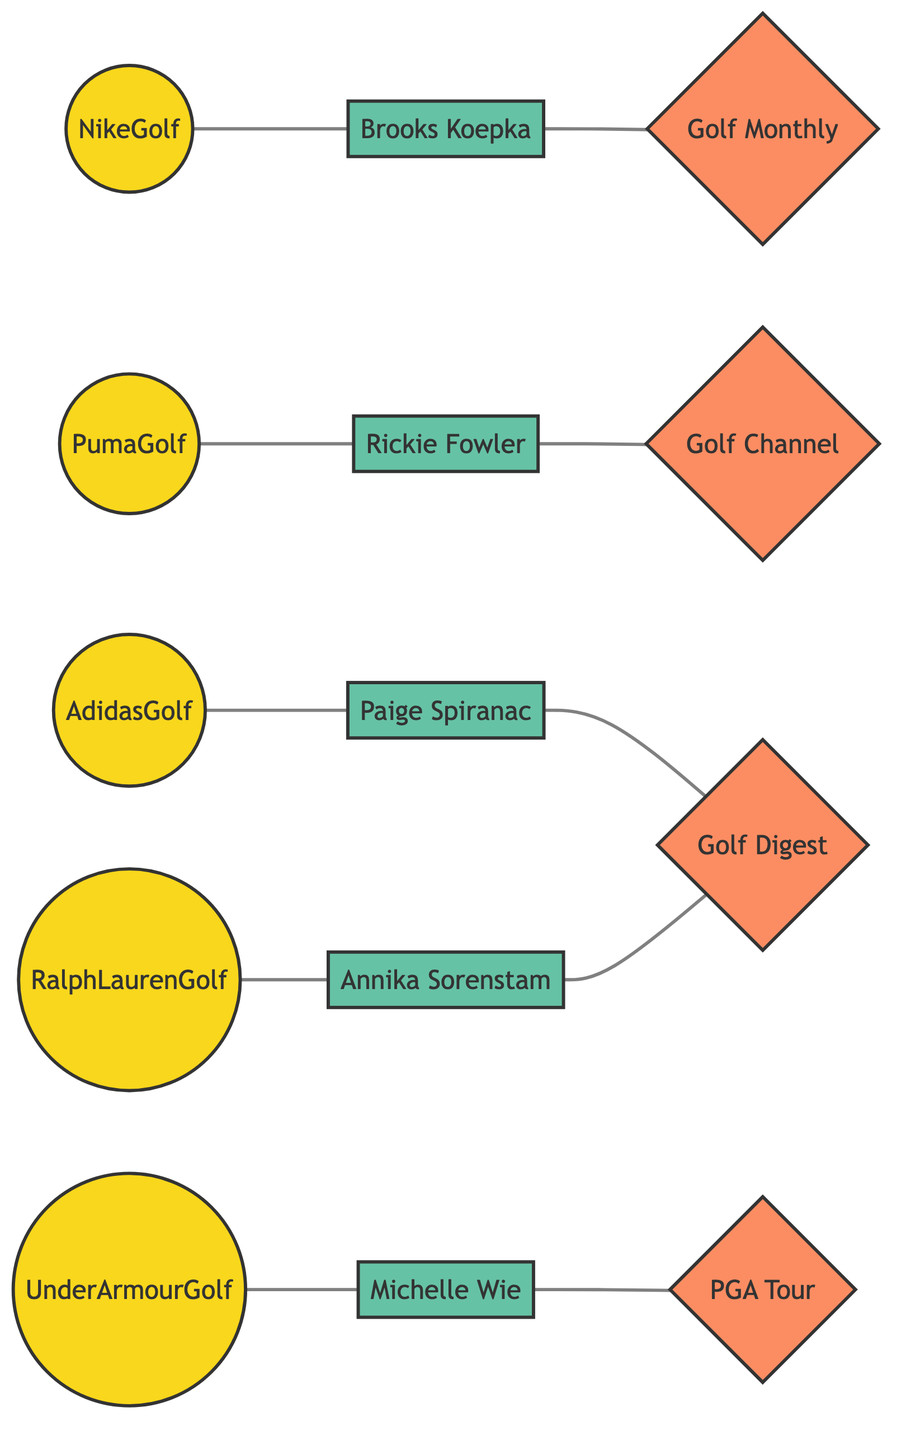What is the total number of nodes in the diagram? The diagram includes both brands and influencers, plus media entities. By counting all unique nodes listed, we find there are 13 nodes in total.
Answer: 13 Which influencer is associated with Nike Golf? The diagram shows a direct edge connecting Nike Golf and Brooks Koepka. This indicates that Brooks Koepka is the influencer associated with Nike Golf.
Answer: Brooks Koepka How many collaborations are featured in the diagram? By examining the edges, we note that there are 5 edges labeled as collaborations connecting different brands to influencers. This gives us a total of 5 collaboration relationships.
Answer: 5 Which brand is connected to GolfDigest? The edges indicate that Paige Spiranac and Annika Sorenstam are both connected to GolfDigest. Therefore, the brands associated with GolfDigest through these influencers indirectly highlight their connections.
Answer: Adidas Golf, Ralph Lauren Golf Who has the most connections in the diagram? To determine this, we count the edges connected to each influencer. Brooks Koepka, Paige Spiranac, and Annika Sorenstam each have one direct brand collaboration and one media feature. However, since Brooks Koepka also has a connection with Golf Monthly, he has the highest overall connections.
Answer: Brooks Koepka What type of connection exists between Puma Golf and Rickie Fowler? The diagram explicitly shows a direct edge labeled as a collaboration between Puma Golf and Rickie Fowler. This indicates their relationship type as a collaboration.
Answer: Collaboration How many media entities are featured? By inspecting the nodes specifically categorized under media, we find there are 4 distinct media entities listed in the diagram.
Answer: 4 Which influencer is linked to Under Armour Golf? The edge connects Under Armour Golf directly to Michelle Wie, which establishes her as the influencer associated with this brand.
Answer: Michelle Wie Is there any overlap of connections between GolfDigest and the influencers? Yes, the diagram reveals that both Paige Spiranac and Annika Sorenstam are connected to GolfDigest, leading to a clear overlap of connections between this media entity and the influencers.
Answer: Yes What is the relationship type between Michelle Wie and the PGA Tour? The diagram indicates that Michelle Wie has a direct edge to the PGA Tour, marked as a feature. Hence, the relationship between them is categorized as a feature.
Answer: Feature 